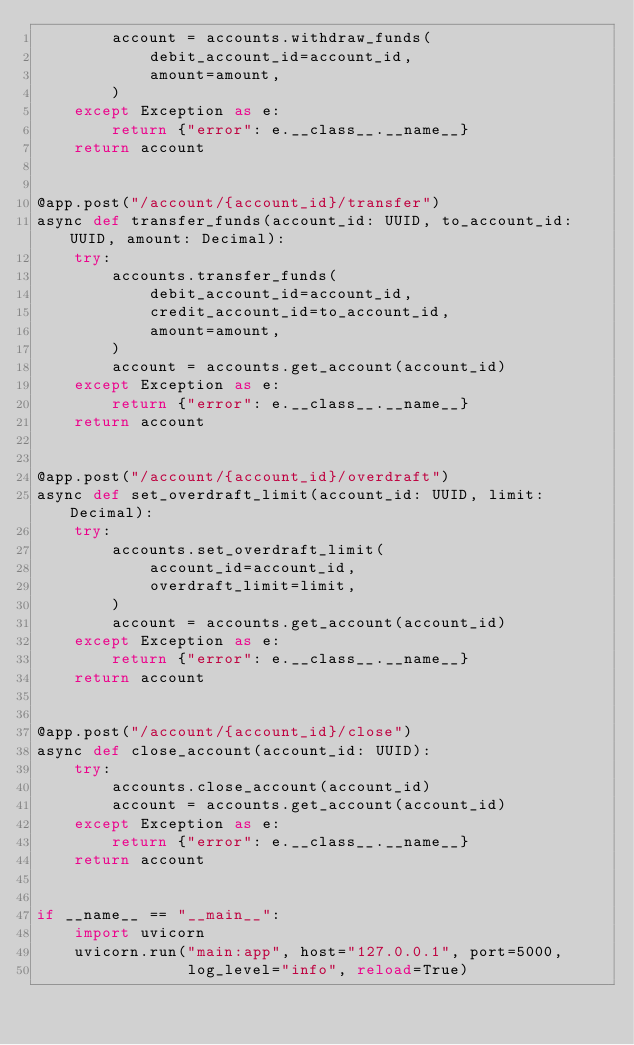Convert code to text. <code><loc_0><loc_0><loc_500><loc_500><_Python_>        account = accounts.withdraw_funds(
            debit_account_id=account_id,
            amount=amount,
        )
    except Exception as e:
        return {"error": e.__class__.__name__}
    return account


@app.post("/account/{account_id}/transfer")
async def transfer_funds(account_id: UUID, to_account_id: UUID, amount: Decimal):
    try:
        accounts.transfer_funds(
            debit_account_id=account_id,
            credit_account_id=to_account_id,
            amount=amount,
        )
        account = accounts.get_account(account_id)
    except Exception as e:
        return {"error": e.__class__.__name__}
    return account


@app.post("/account/{account_id}/overdraft")
async def set_overdraft_limit(account_id: UUID, limit: Decimal):
    try:
        accounts.set_overdraft_limit(
            account_id=account_id,
            overdraft_limit=limit,
        )
        account = accounts.get_account(account_id)
    except Exception as e:
        return {"error": e.__class__.__name__}
    return account


@app.post("/account/{account_id}/close")
async def close_account(account_id: UUID):
    try:
        accounts.close_account(account_id)
        account = accounts.get_account(account_id)
    except Exception as e:
        return {"error": e.__class__.__name__}
    return account


if __name__ == "__main__":
    import uvicorn
    uvicorn.run("main:app", host="127.0.0.1", port=5000,
                log_level="info", reload=True)
</code> 